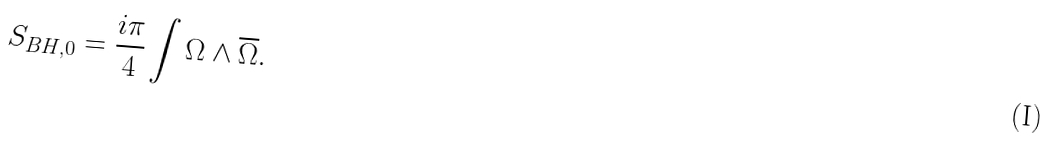<formula> <loc_0><loc_0><loc_500><loc_500>S _ { B H , 0 } = \frac { i \pi } { 4 } \int \Omega \wedge \overline { \Omega } .</formula> 